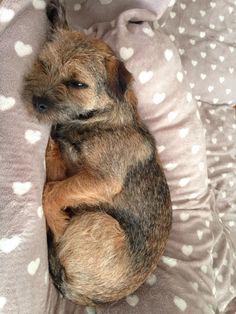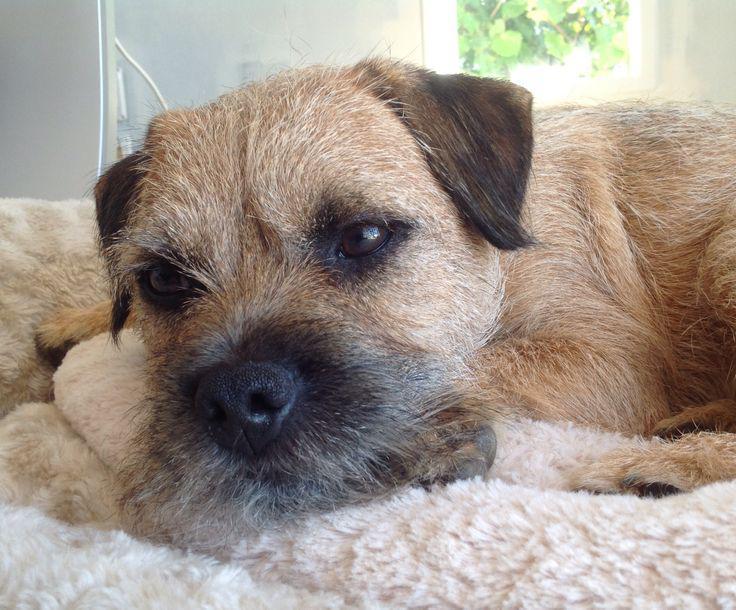The first image is the image on the left, the second image is the image on the right. Examine the images to the left and right. Is the description "An image shows a dog in a sleeping pose on a patterned fabric." accurate? Answer yes or no. Yes. The first image is the image on the left, the second image is the image on the right. For the images shown, is this caption "There are three dogs,  dog on the right is looking straight at the camera, as if making eye contact." true? Answer yes or no. No. 